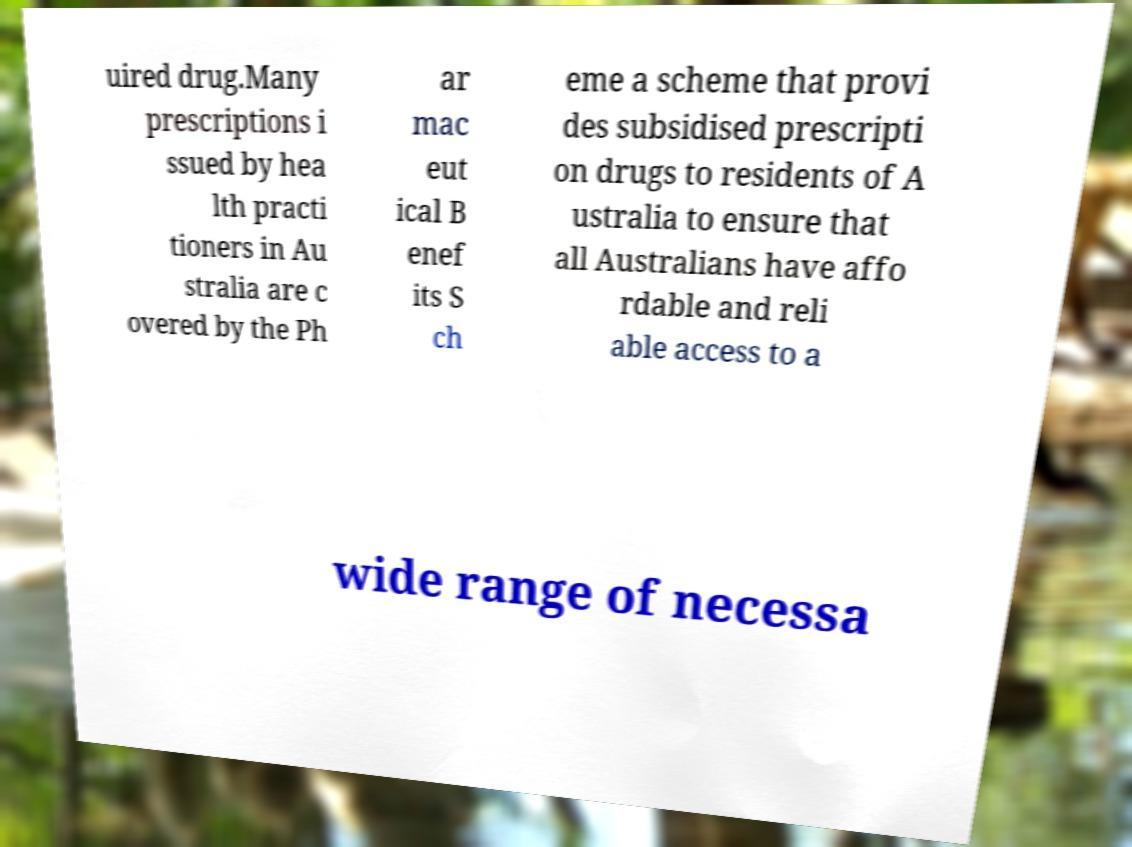Please identify and transcribe the text found in this image. uired drug.Many prescriptions i ssued by hea lth practi tioners in Au stralia are c overed by the Ph ar mac eut ical B enef its S ch eme a scheme that provi des subsidised prescripti on drugs to residents of A ustralia to ensure that all Australians have affo rdable and reli able access to a wide range of necessa 